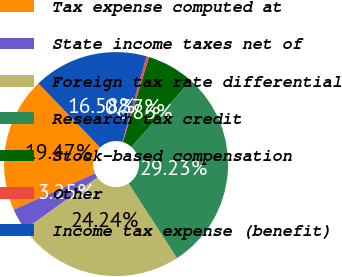<chart> <loc_0><loc_0><loc_500><loc_500><pie_chart><fcel>Tax expense computed at<fcel>State income taxes net of<fcel>Foreign tax rate differential<fcel>Research tax credit<fcel>Stock-based compensation<fcel>Other<fcel>Income tax expense (benefit)<nl><fcel>19.47%<fcel>3.25%<fcel>24.24%<fcel>29.23%<fcel>6.86%<fcel>0.37%<fcel>16.58%<nl></chart> 